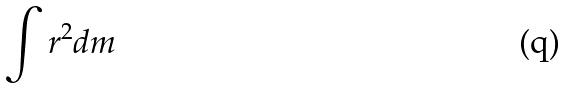Convert formula to latex. <formula><loc_0><loc_0><loc_500><loc_500>\int r ^ { 2 } d m</formula> 